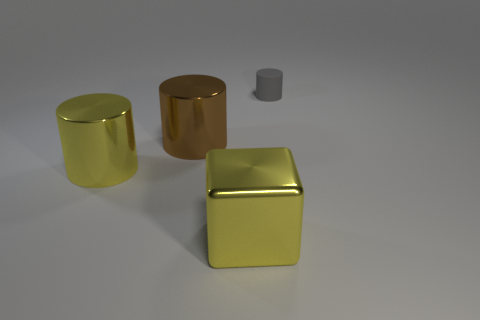Add 4 yellow matte cubes. How many objects exist? 8 Subtract all shiny objects. Subtract all big spheres. How many objects are left? 1 Add 1 brown cylinders. How many brown cylinders are left? 2 Add 3 gray rubber things. How many gray rubber things exist? 4 Subtract 0 red cubes. How many objects are left? 4 Subtract all cubes. How many objects are left? 3 